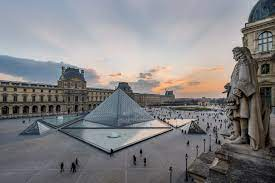What is the atmosphere in the Louvre courtyard like? The Louvre courtyard is a bustling hub of activity and excitement. It is a meeting point for art enthusiasts, tourists, and locals alike. The atmosphere is vibrant and dynamic, with people moving to and from the museum's entrance, taking photos, or simply enjoying the stunning surroundings. The blend of voices, footsteps on the stone paving, and the gentle splash of water from the fountains contributes to the vibrant yet orderly atmosphere of this historic landmark. 